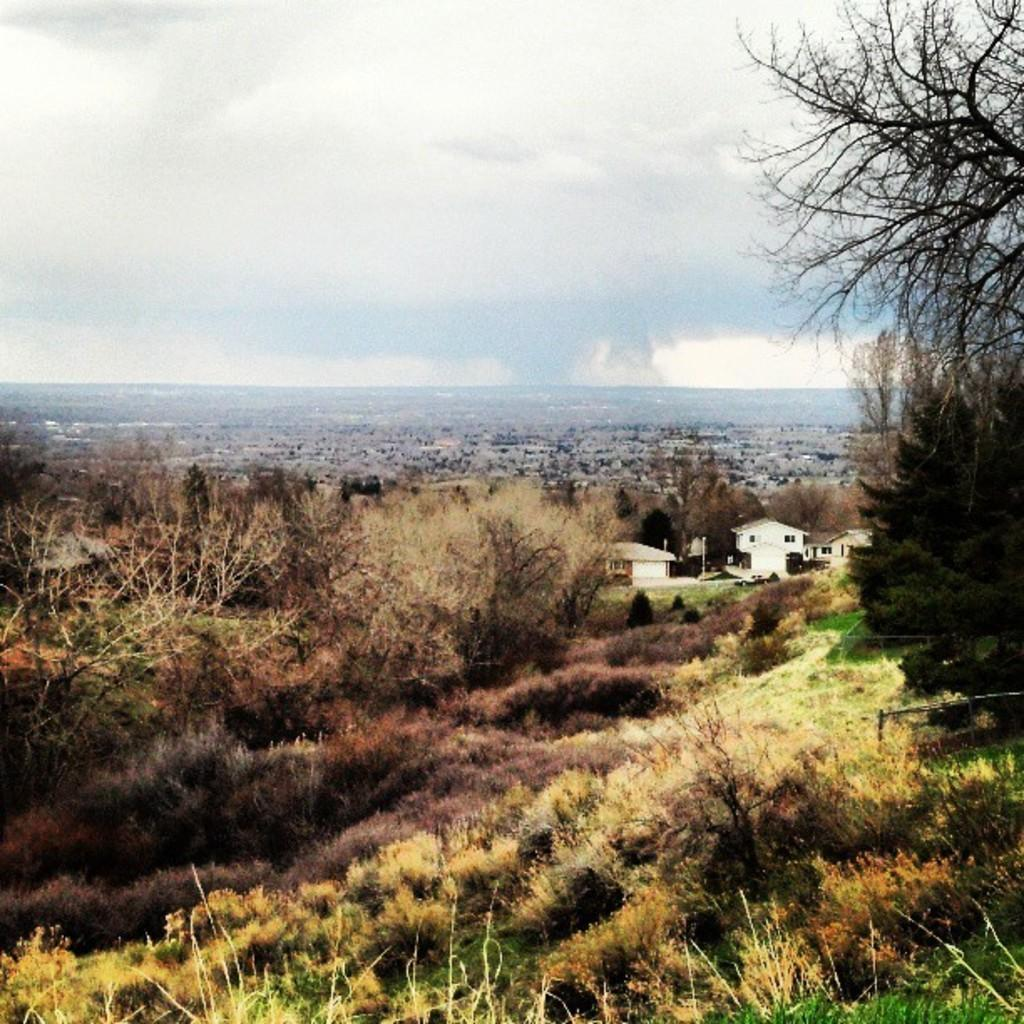What type of vegetation can be seen in the image? There are trees and plants in the image. What structures are visible in the background of the image? There are buildings in the background of the image. What is visible in the sky in the image? The sky is visible in the background of the image, and clouds are present. What type of underwear is hanging on the trees in the image? There is no underwear present in the image; it only features trees, plants, buildings, and the sky with clouds. 